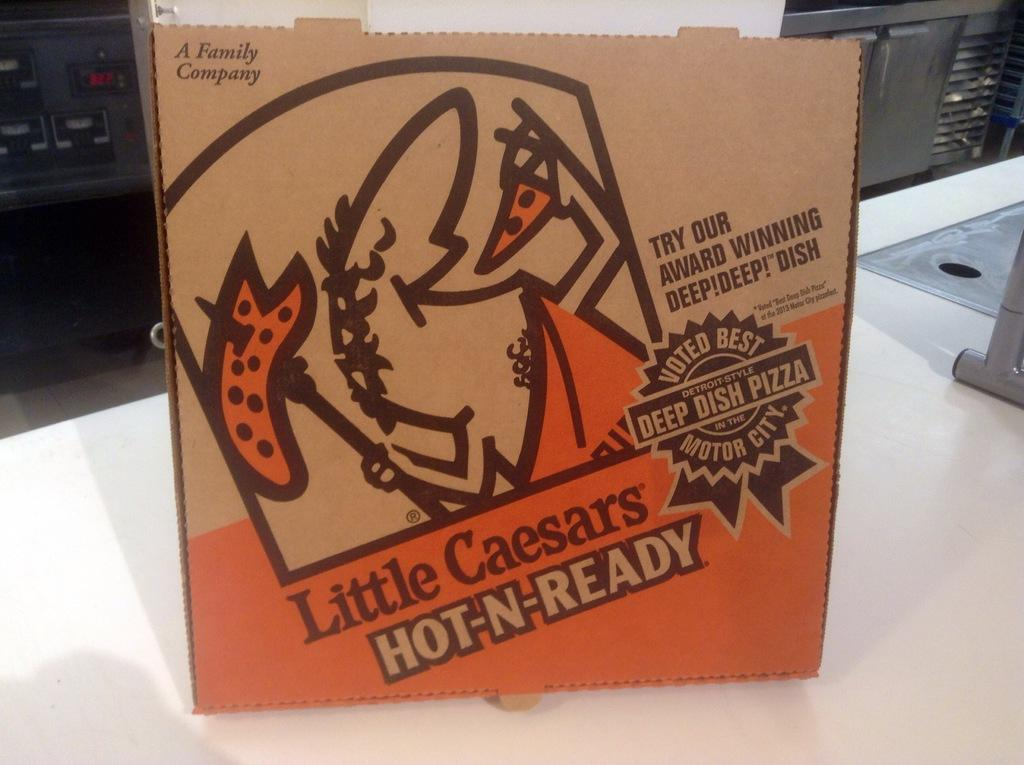<image>
Offer a succinct explanation of the picture presented. The pizza in this box is described as award winning and voted best. 